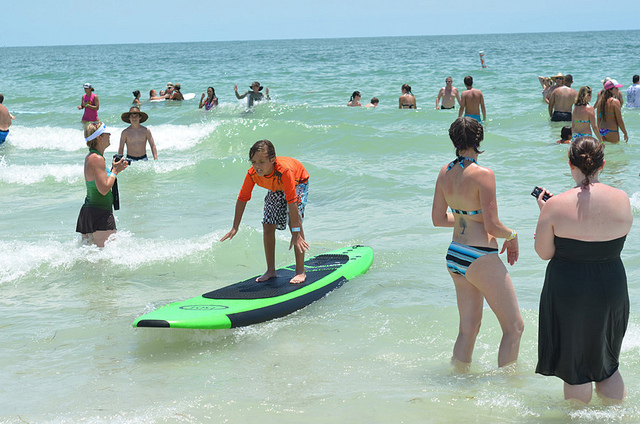Describe a realistic scenario that could happen next in this scene. The boy on the surfboard might paddle out further into the ocean, attempting to catch a bigger wave. Meanwhile, the woman in the striped swimsuit could capture the moment with her camera, as the others continue enjoying their swim and sunbath. What might the people do after they finish their activities in the ocean? After their activities in the ocean, the people might gather their belongings and head back to their beach chairs or a picnic spot. They might dry off using towels, reapply sunscreen, and have some snacks or drinks. Some might take a nap under the shade while others engage in beach games like volleyball or frisbee. As the day progresses, they might stay to watch the sunset, enjoying the serene end to a day full of fun and relaxation. 